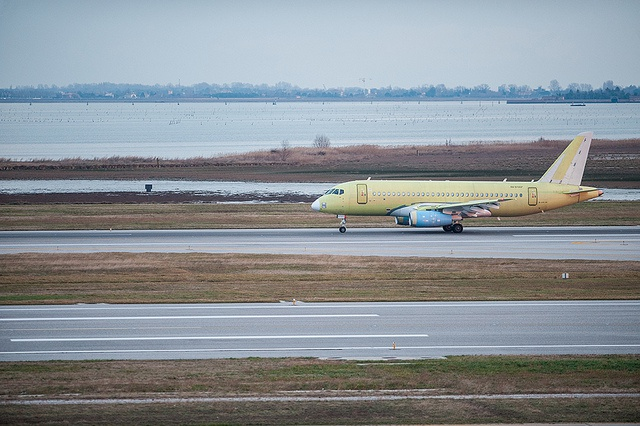Describe the objects in this image and their specific colors. I can see airplane in darkgray, beige, lightgray, and tan tones and boat in darkgray, darkblue, gray, and lightblue tones in this image. 